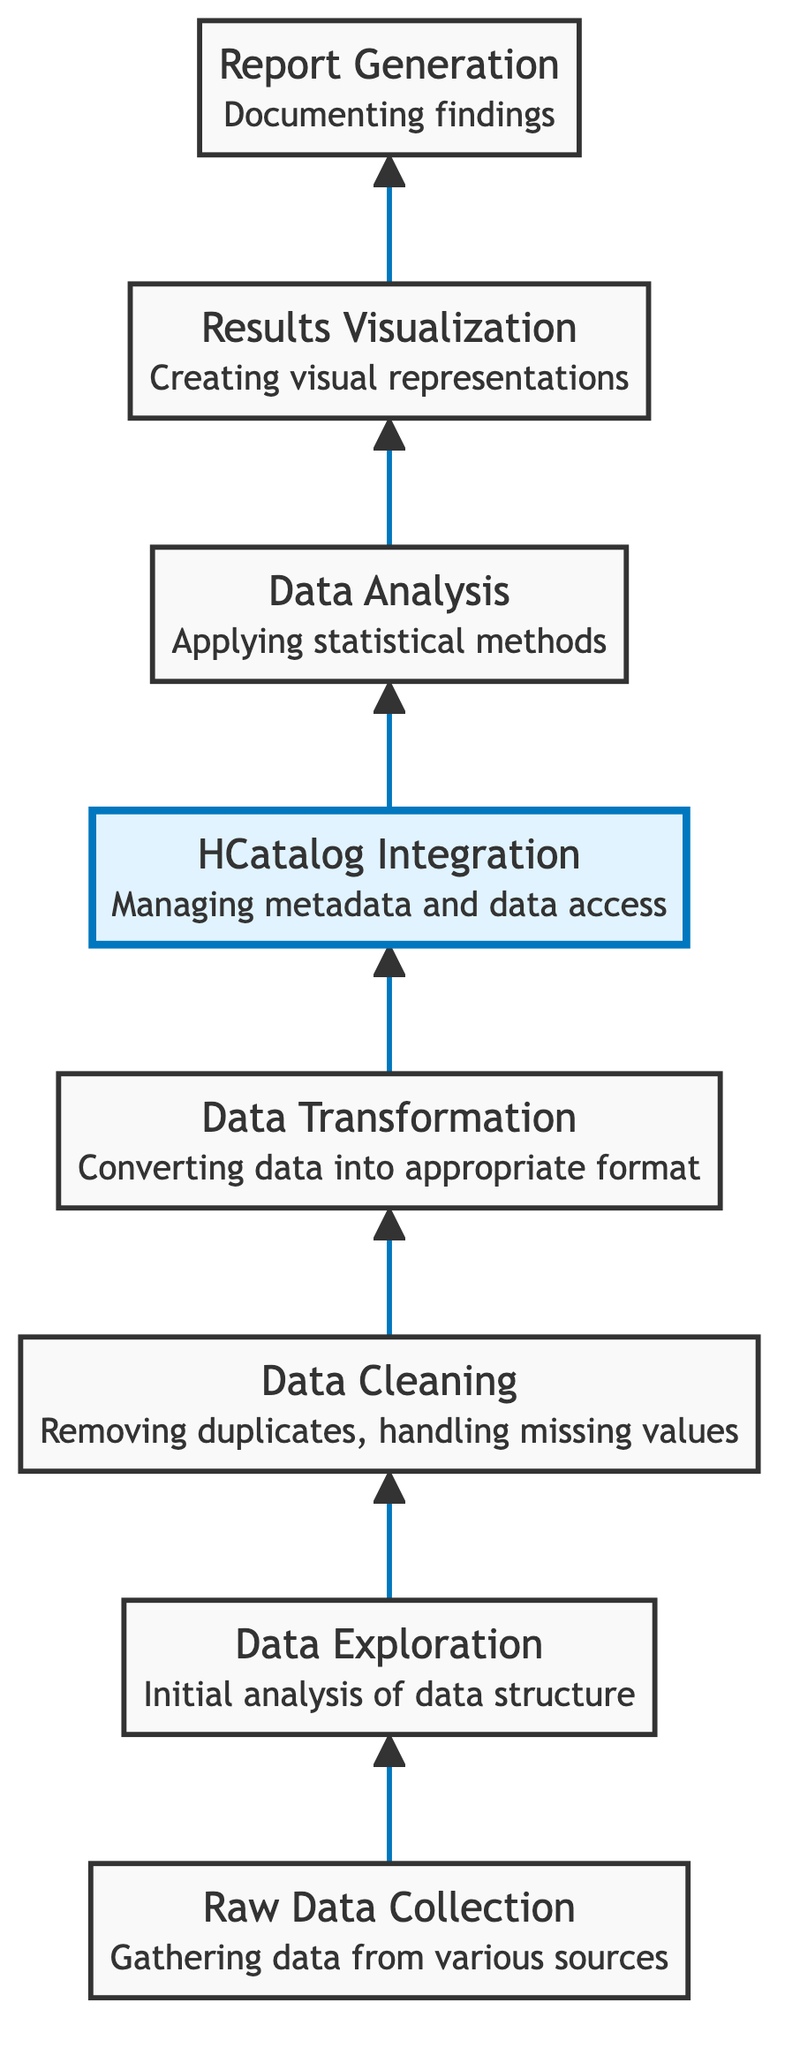What is the first step in the workflow? The first step in the workflow is identified as "Raw Data Collection" in the diagram, which gathers data from various sources.
Answer: Raw Data Collection How many nodes are there in the diagram? By counting the elements listed in the diagram, there are a total of 8 distinct nodes.
Answer: 8 Which step follows "Data Cleaning"? The diagram shows that "Data Transformation" follows "Data Cleaning," indicating the process flow from one step to the next.
Answer: Data Transformation What is the purpose of HCatalog Integration? The purpose of HCatalog Integration is to manage metadata and access cleaned and transformed data, as stated in its description within the diagram.
Answer: Managing metadata and data access Which step comes after "Results Visualization"? According to the flow of the diagram, "Report Generation" is the step that follows "Results Visualization."
Answer: Report Generation How many steps are involved before data analysis? The steps before "Data Analysis" are "Raw Data Collection," "Data Exploration," "Data Cleaning," "Data Transformation," and "HCatalog Integration." By counting these, we find there are 5 steps before reaching "Data Analysis."
Answer: 5 What is the relationship between "Data Transformation" and "HCatalog Integration"? The diagram indicates a directional flow from "Data Transformation" to "HCatalog Integration," showing that "Data Transformation" feeds its output into "HCatalog Integration."
Answer: Data flow Name the last step in the cleaning and transformation workflow. The last step in the workflow is "Report Generation," which documents findings and methodologies for sharing with stakeholders.
Answer: Report Generation What is the highlighted step in the diagram? The highlighted step is "HCatalog Integration," which is emphasized graphically to indicate its importance in managing data.
Answer: HCatalog Integration 